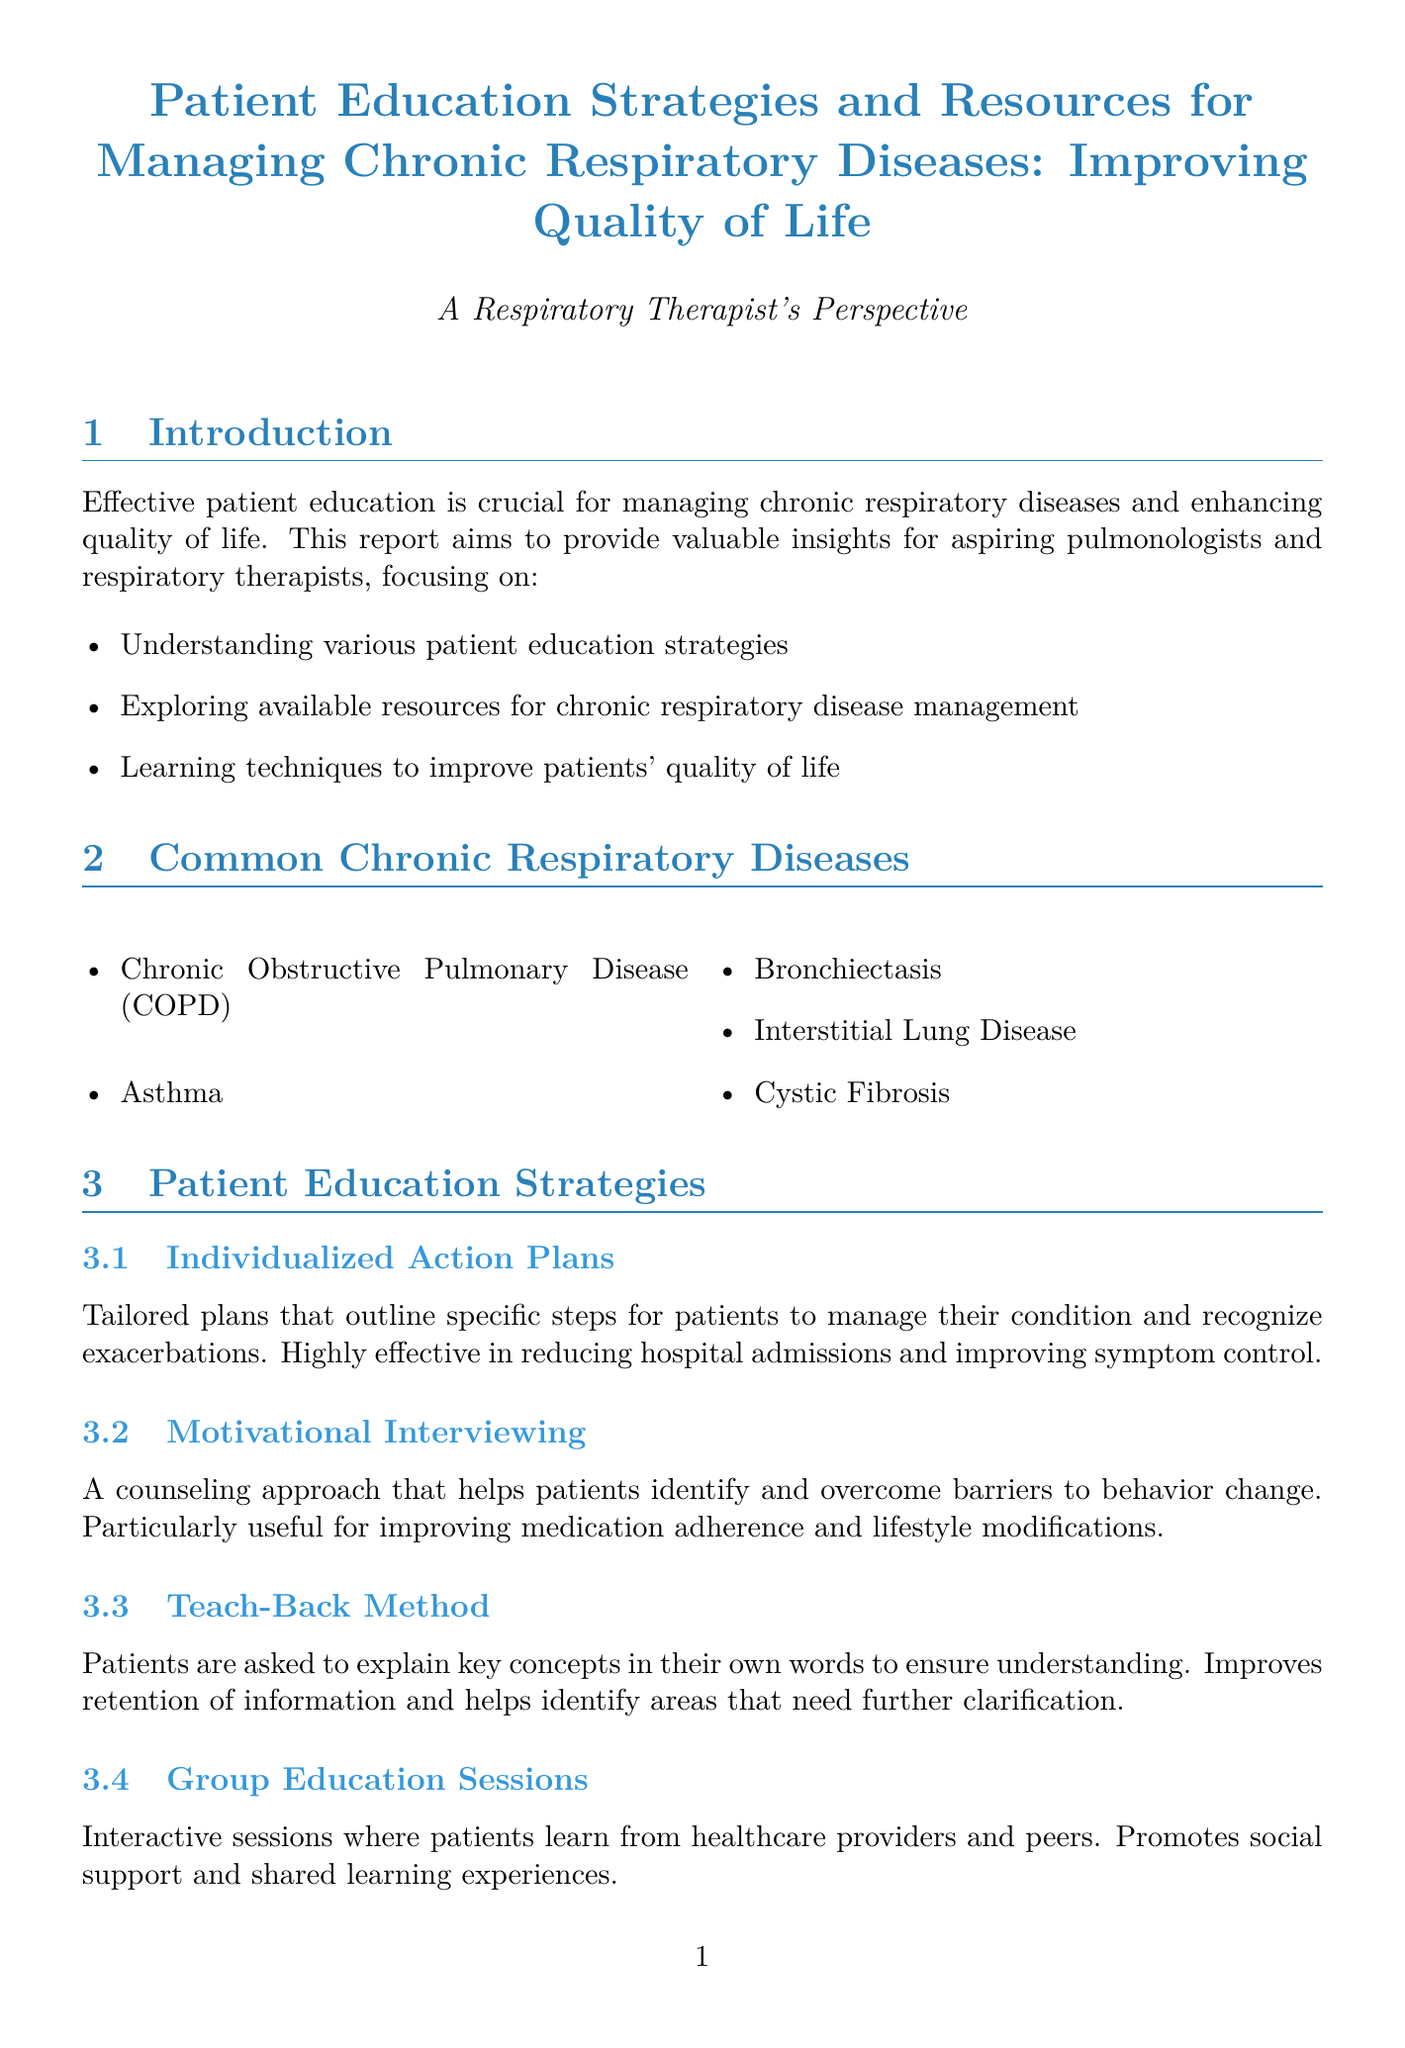What is the title of the report? The title of the report is clearly stated at the beginning of the document.
Answer: Patient Education Strategies and Resources for Managing Chronic Respiratory Diseases: Improving Quality of Life Who is the target audience for this report? The report specifies who it aims to educate in its introduction section.
Answer: Aspiring pulmonologists and respiratory therapists What are two common chronic respiratory diseases mentioned? The document lists common diseases in a section dedicated to them.
Answer: Chronic Obstructive Pulmonary Disease (COPD), Asthma What educational resource type is a printed material? The resource types are categorized in a section that describes different formats.
Answer: Printed Materials What is one technique for stress management listed? The report details various techniques for improving quality of life through different categories.
Answer: Mindfulness and meditation practices What was the percentage reduction in hospital readmissions at Cleveland Clinic? The outcomes of this case study provide specific numerical results in the document.
Answer: 30% What method is described as effective for improving medication adherence? The document summarizes patient education strategies and their effectiveness.
Answer: Motivational Interviewing What is the call to action for aspiring pulmonologists? The conclusion outlines what is recommended for the target audience to enhance patient care.
Answer: Prioritize developing strong patient education skills 